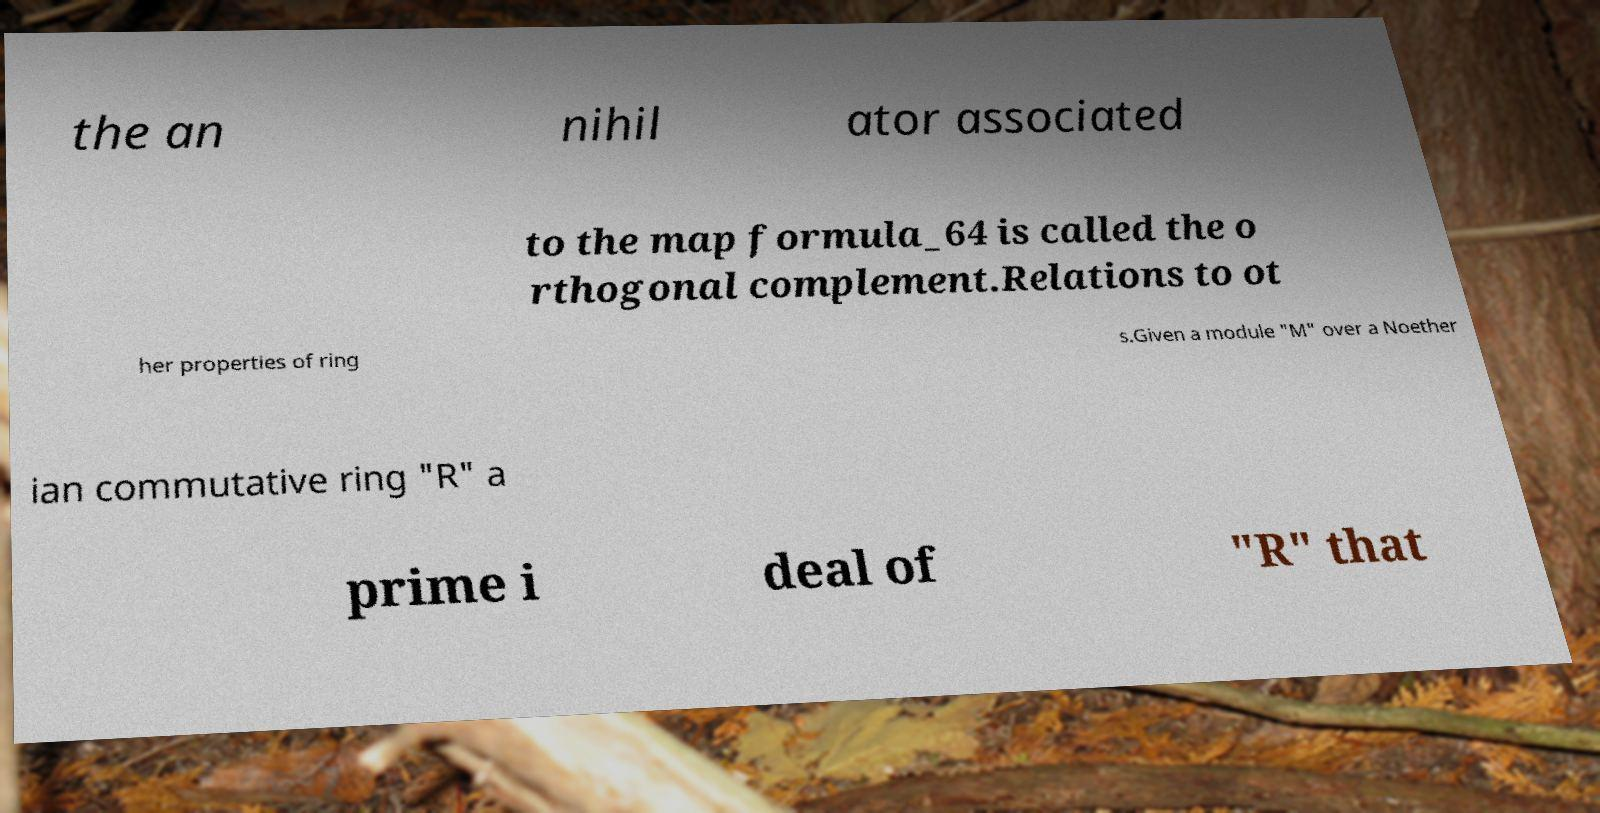What messages or text are displayed in this image? I need them in a readable, typed format. the an nihil ator associated to the map formula_64 is called the o rthogonal complement.Relations to ot her properties of ring s.Given a module "M" over a Noether ian commutative ring "R" a prime i deal of "R" that 